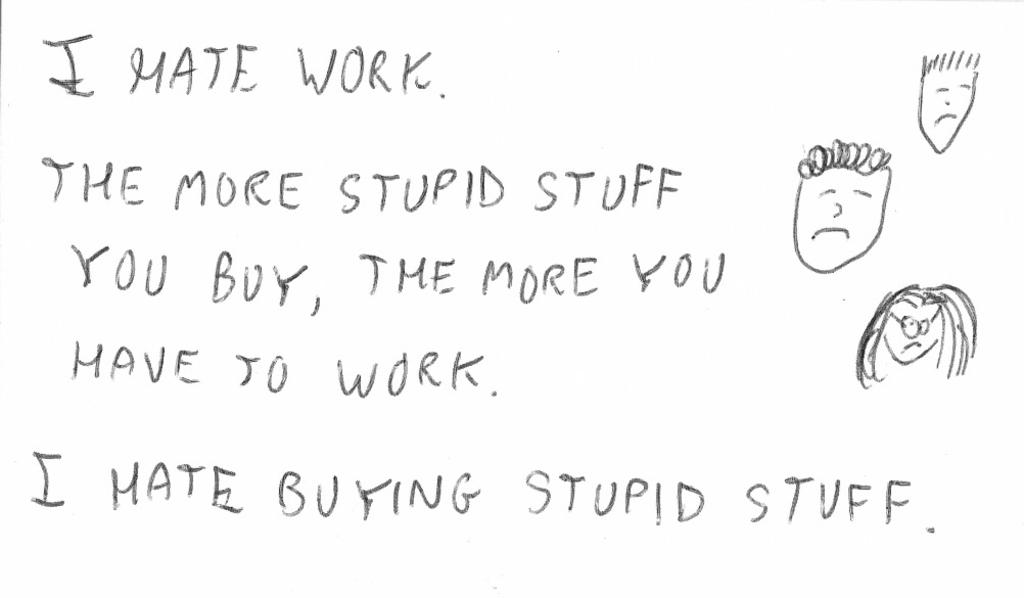What is present in the image that contains written information? There is a poster in the image that contains text. What else can be found on the poster besides text? The poster contains drawing images. What action is the poster performing in the image? The poster is not performing any action in the image; it is a static object. 